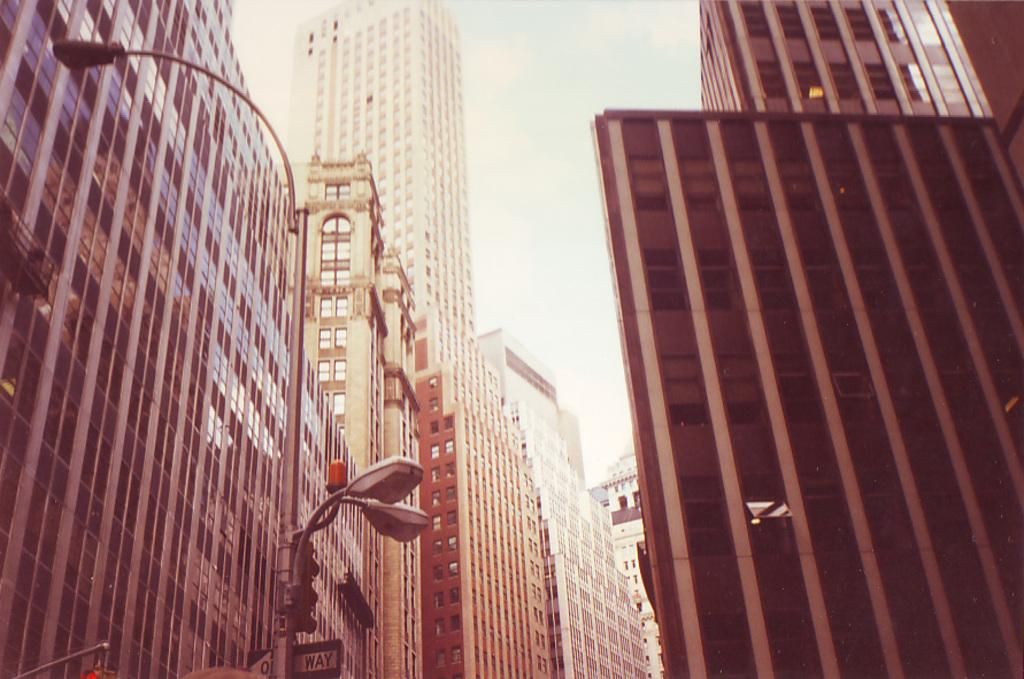<image>
Give a short and clear explanation of the subsequent image. A streetlight with a sign that has the word WAY visible on it 